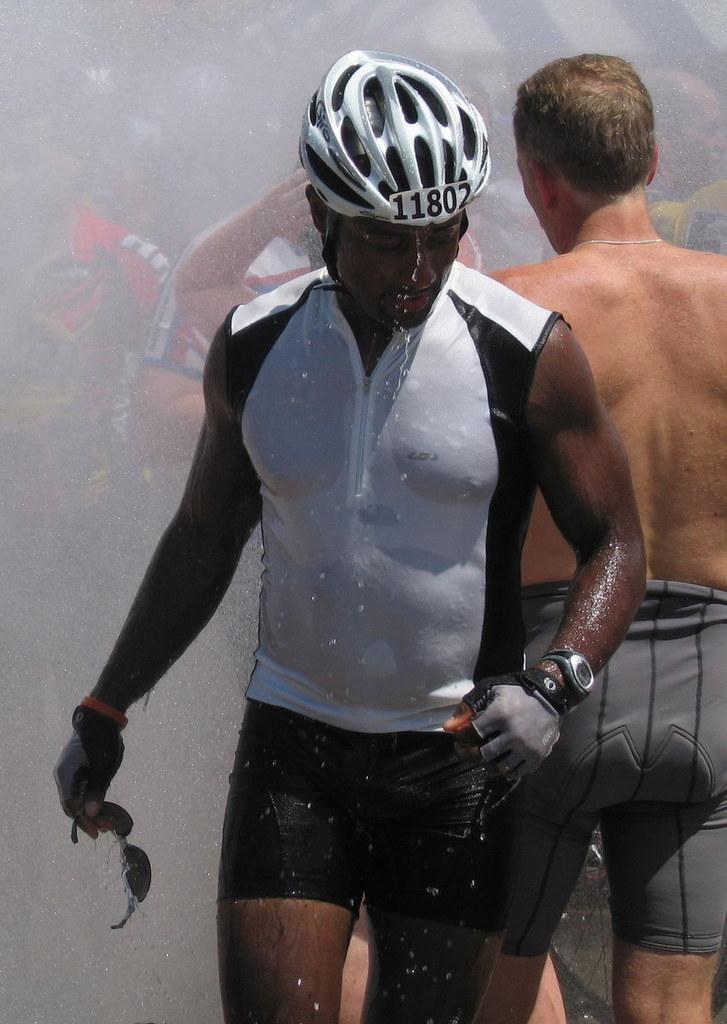What is the man in the image wearing on his upper body? The man is wearing a white T-shirt in the image. What type of headgear is the man wearing? The man is wearing a white helmet in the image. What is the man holding in his hand? The man is holding goggles in his hand. Can you describe the people behind the man? There are people standing behind the man in the image. How would you describe the background of the image? The background of the image is blurred. What type of harmony is being played by the iron in the image? There is no iron present in the image, and therefore no harmony can be played. 